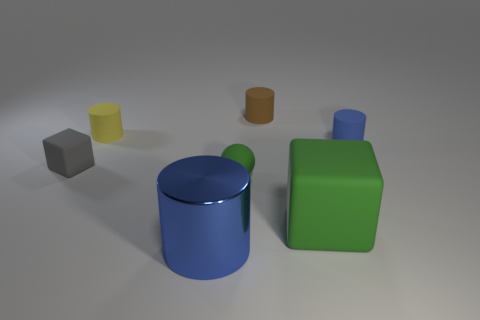Are the large blue cylinder and the blue cylinder behind the small green thing made of the same material?
Offer a very short reply. No. What size is the brown cylinder that is the same material as the large cube?
Keep it short and to the point. Small. Are there any big yellow matte objects that have the same shape as the brown rubber thing?
Your answer should be compact. No. What number of objects are objects that are to the right of the green rubber sphere or large matte objects?
Your response must be concise. 3. What is the size of the block that is the same color as the matte ball?
Your answer should be compact. Large. There is a cylinder left of the large blue cylinder; is its color the same as the cylinder that is in front of the blue matte cylinder?
Your answer should be very brief. No. The green block has what size?
Your answer should be compact. Large. What number of tiny objects are either red cubes or blue matte objects?
Provide a succinct answer. 1. There is a ball that is the same size as the yellow rubber cylinder; what color is it?
Offer a very short reply. Green. What number of other things are there of the same shape as the blue matte object?
Your answer should be very brief. 3. 